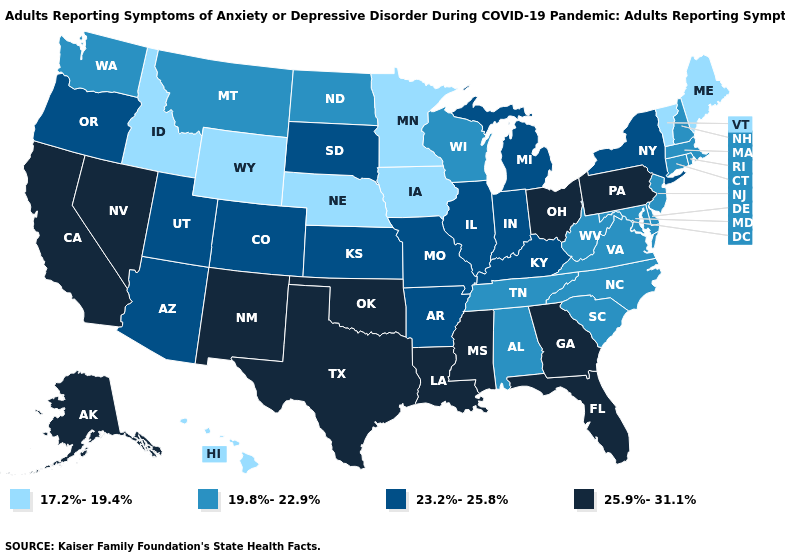Is the legend a continuous bar?
Quick response, please. No. Name the states that have a value in the range 19.8%-22.9%?
Write a very short answer. Alabama, Connecticut, Delaware, Maryland, Massachusetts, Montana, New Hampshire, New Jersey, North Carolina, North Dakota, Rhode Island, South Carolina, Tennessee, Virginia, Washington, West Virginia, Wisconsin. What is the lowest value in the West?
Quick response, please. 17.2%-19.4%. What is the value of Missouri?
Write a very short answer. 23.2%-25.8%. Name the states that have a value in the range 17.2%-19.4%?
Quick response, please. Hawaii, Idaho, Iowa, Maine, Minnesota, Nebraska, Vermont, Wyoming. Which states have the lowest value in the USA?
Be succinct. Hawaii, Idaho, Iowa, Maine, Minnesota, Nebraska, Vermont, Wyoming. Does Illinois have a higher value than Oklahoma?
Quick response, please. No. Name the states that have a value in the range 25.9%-31.1%?
Keep it brief. Alaska, California, Florida, Georgia, Louisiana, Mississippi, Nevada, New Mexico, Ohio, Oklahoma, Pennsylvania, Texas. Is the legend a continuous bar?
Concise answer only. No. What is the highest value in the South ?
Concise answer only. 25.9%-31.1%. Name the states that have a value in the range 25.9%-31.1%?
Answer briefly. Alaska, California, Florida, Georgia, Louisiana, Mississippi, Nevada, New Mexico, Ohio, Oklahoma, Pennsylvania, Texas. Which states have the highest value in the USA?
Answer briefly. Alaska, California, Florida, Georgia, Louisiana, Mississippi, Nevada, New Mexico, Ohio, Oklahoma, Pennsylvania, Texas. Name the states that have a value in the range 19.8%-22.9%?
Write a very short answer. Alabama, Connecticut, Delaware, Maryland, Massachusetts, Montana, New Hampshire, New Jersey, North Carolina, North Dakota, Rhode Island, South Carolina, Tennessee, Virginia, Washington, West Virginia, Wisconsin. Is the legend a continuous bar?
Answer briefly. No. 